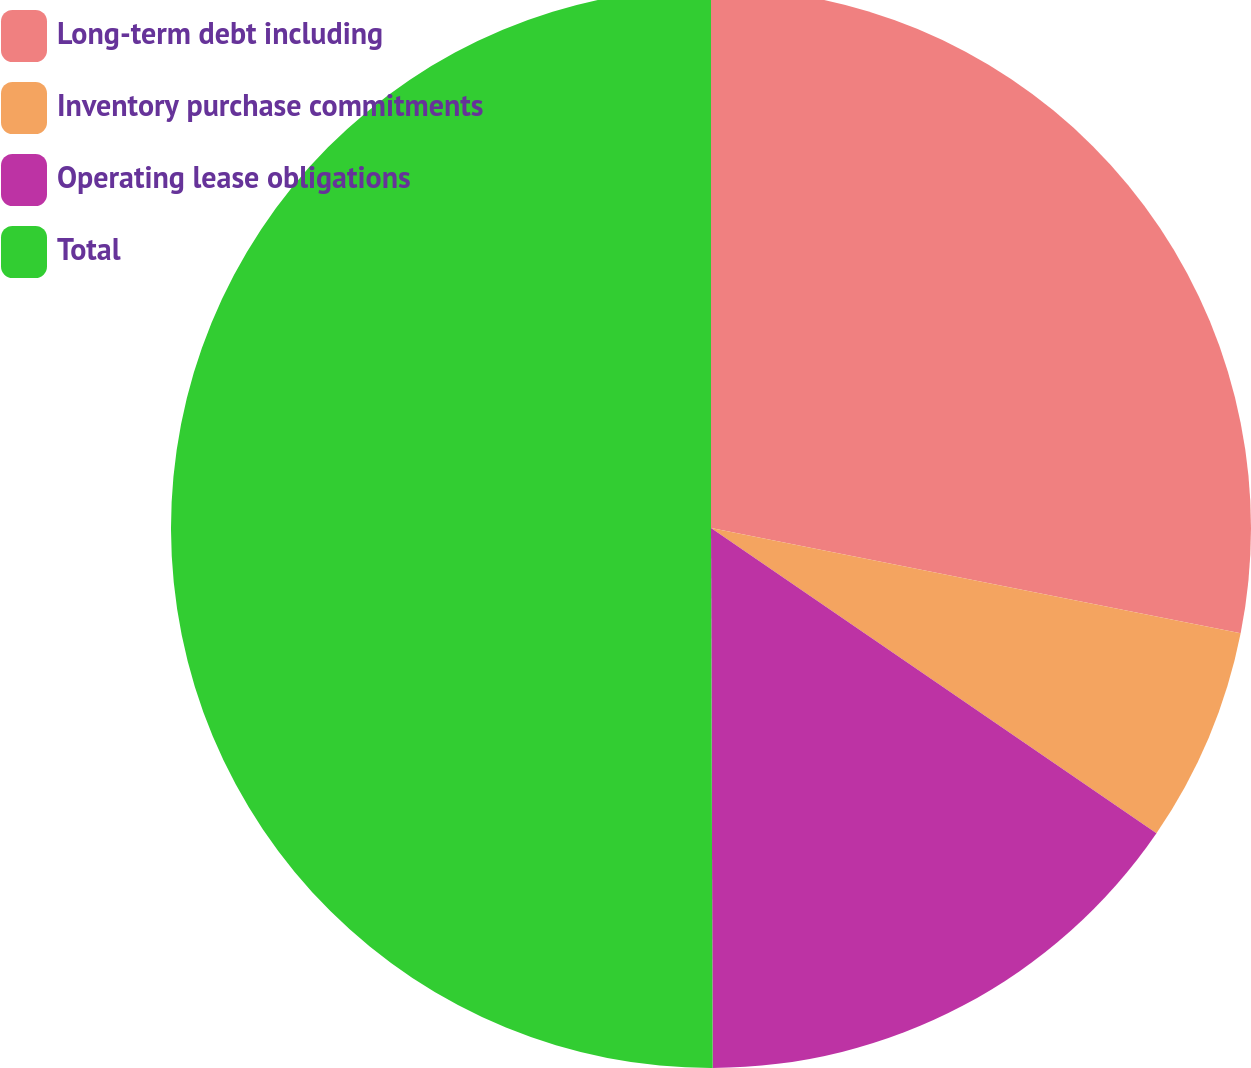Convert chart to OTSL. <chart><loc_0><loc_0><loc_500><loc_500><pie_chart><fcel>Long-term debt including<fcel>Inventory purchase commitments<fcel>Operating lease obligations<fcel>Total<nl><fcel>28.12%<fcel>6.44%<fcel>15.39%<fcel>50.05%<nl></chart> 